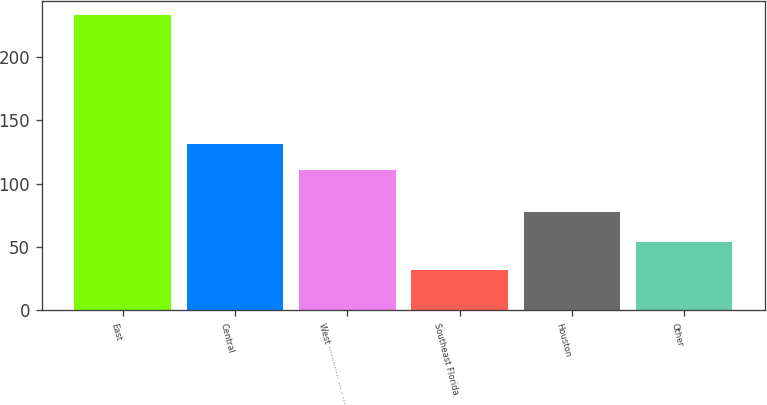<chart> <loc_0><loc_0><loc_500><loc_500><bar_chart><fcel>East<fcel>Central<fcel>West ············· ··· · ···<fcel>Southeast Florida<fcel>Houston<fcel>Other<nl><fcel>233<fcel>131.1<fcel>111<fcel>32<fcel>78<fcel>54<nl></chart> 